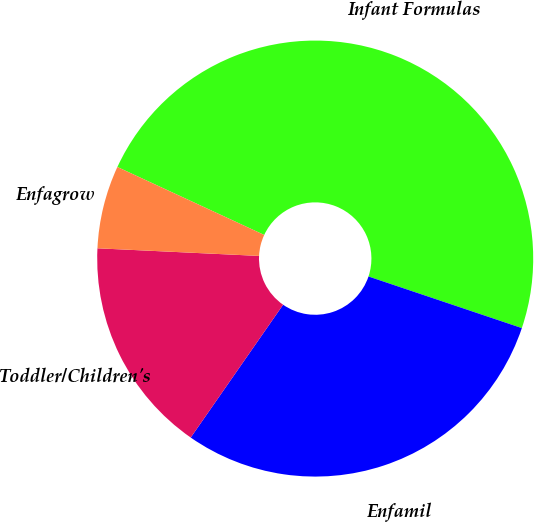Convert chart. <chart><loc_0><loc_0><loc_500><loc_500><pie_chart><fcel>Infant Formulas<fcel>Enfamil<fcel>Toddler/Children's<fcel>Enfagrow<nl><fcel>48.27%<fcel>29.51%<fcel>16.08%<fcel>6.15%<nl></chart> 